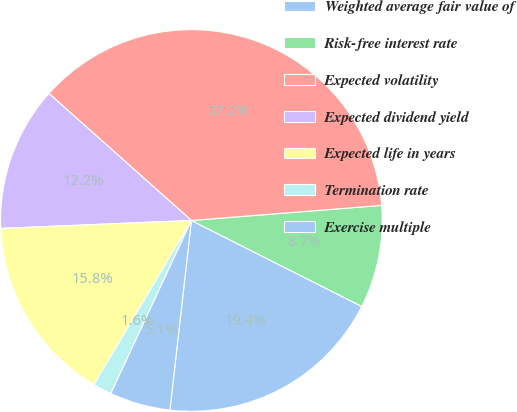Convert chart to OTSL. <chart><loc_0><loc_0><loc_500><loc_500><pie_chart><fcel>Weighted average fair value of<fcel>Risk-free interest rate<fcel>Expected volatility<fcel>Expected dividend yield<fcel>Expected life in years<fcel>Termination rate<fcel>Exercise multiple<nl><fcel>19.36%<fcel>8.7%<fcel>37.16%<fcel>12.25%<fcel>15.81%<fcel>1.59%<fcel>5.14%<nl></chart> 